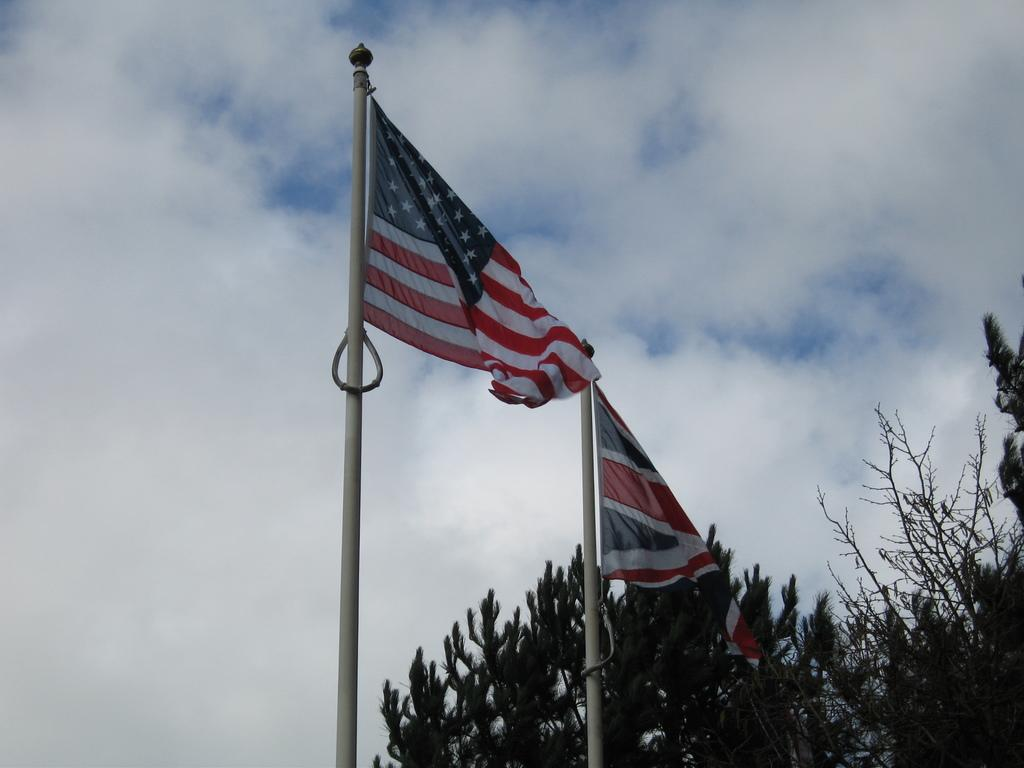What objects are present in the image that are white in color? There are two white-colored poles in the image. What is attached to the poles? Flags are attached to the poles. What can be seen in the background of the image? There are trees and the sky visible in the background of the image. How many pigs are visible in the image? There are no pigs present in the image. What type of utensil is being used by the pigs in the image? There are no pigs or utensils present in the image. 